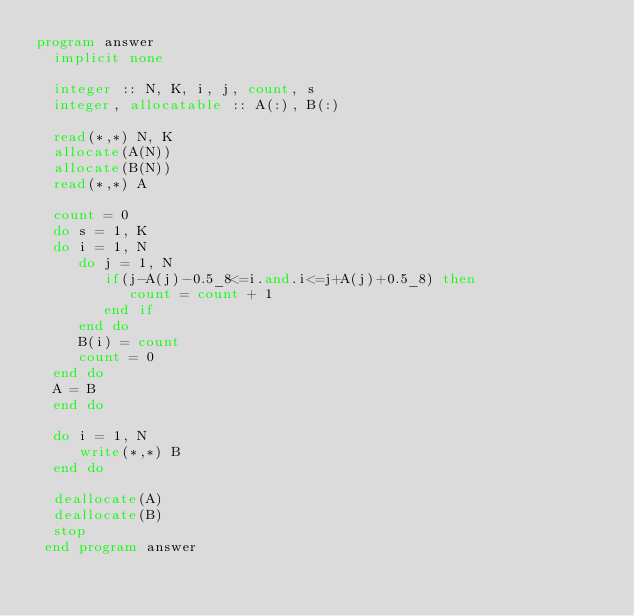Convert code to text. <code><loc_0><loc_0><loc_500><loc_500><_FORTRAN_>program answer
  implicit none

  integer :: N, K, i, j, count, s
  integer, allocatable :: A(:), B(:)

  read(*,*) N, K
  allocate(A(N))
  allocate(B(N))
  read(*,*) A

  count = 0
  do s = 1, K
  do i = 1, N
     do j = 1, N
        if(j-A(j)-0.5_8<=i.and.i<=j+A(j)+0.5_8) then
           count = count + 1
        end if
     end do
     B(i) = count
     count = 0
  end do
  A = B
  end do

  do i = 1, N
     write(*,*) B
  end do

  deallocate(A)
  deallocate(B)
  stop
 end program answer
  
</code> 